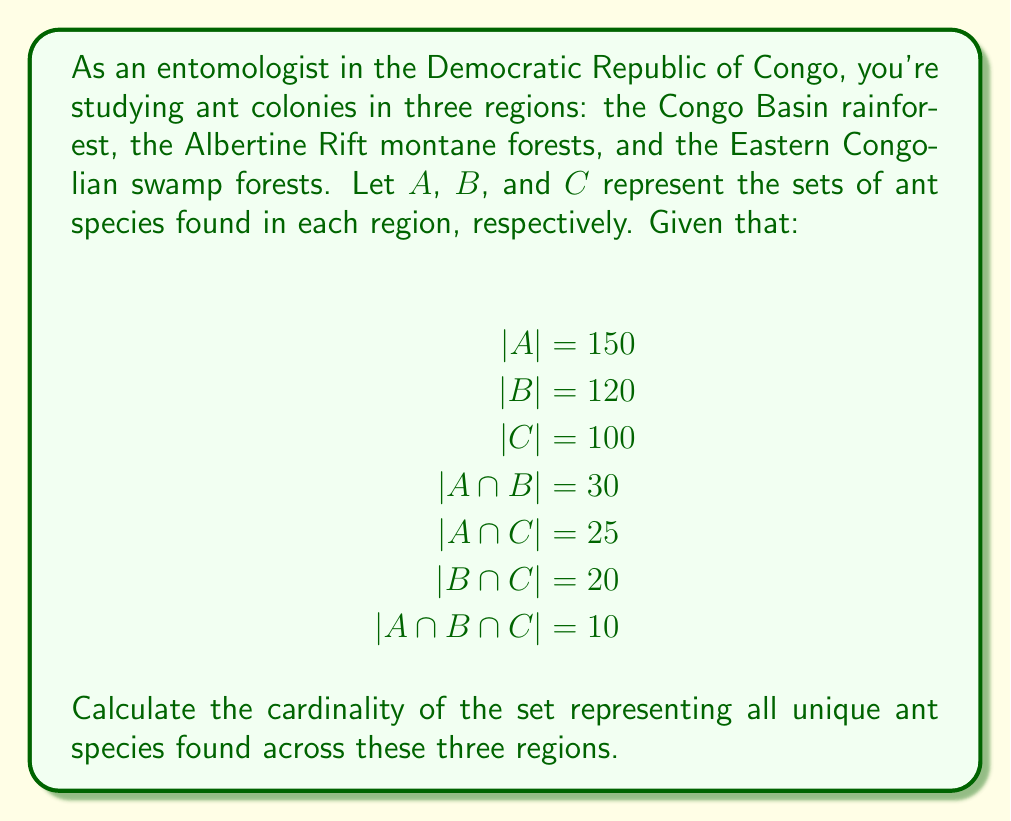Teach me how to tackle this problem. To solve this problem, we'll use the Inclusion-Exclusion Principle for three sets. The formula for the cardinality of the union of three sets is:

$$|A \cup B \cup C| = |A| + |B| + |C| - |A \cap B| - |A \cap C| - |B \cap C| + |A \cap B \cap C|$$

Let's substitute the given values:

$$|A \cup B \cup C| = 150 + 120 + 100 - 30 - 25 - 20 + 10$$

Now, let's calculate step by step:

1) First, add the cardinalities of individual sets:
   $150 + 120 + 100 = 370$

2) Then, subtract the cardinalities of pairwise intersections:
   $370 - 30 - 25 - 20 = 295$

3) Finally, add back the cardinality of the triple intersection:
   $295 + 10 = 305$

Therefore, the cardinality of the union of all three sets is 305.
Answer: The cardinality of the set representing all unique ant species found across the three regions is 305. 